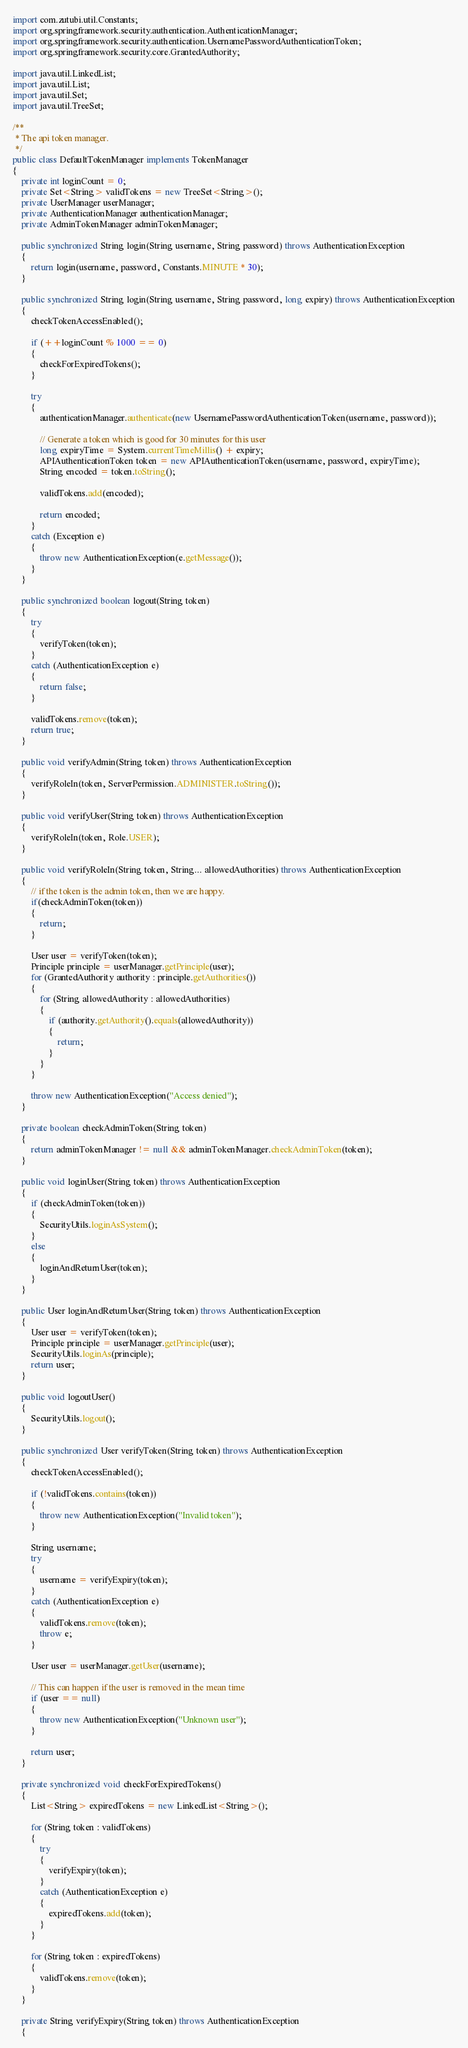<code> <loc_0><loc_0><loc_500><loc_500><_Java_>import com.zutubi.util.Constants;
import org.springframework.security.authentication.AuthenticationManager;
import org.springframework.security.authentication.UsernamePasswordAuthenticationToken;
import org.springframework.security.core.GrantedAuthority;

import java.util.LinkedList;
import java.util.List;
import java.util.Set;
import java.util.TreeSet;

/**
 * The api token manager.
 */
public class DefaultTokenManager implements TokenManager
{
    private int loginCount = 0;
    private Set<String> validTokens = new TreeSet<String>();
    private UserManager userManager;
    private AuthenticationManager authenticationManager;
    private AdminTokenManager adminTokenManager;

    public synchronized String login(String username, String password) throws AuthenticationException
    {
        return login(username, password, Constants.MINUTE * 30);
    }

    public synchronized String login(String username, String password, long expiry) throws AuthenticationException
    {
        checkTokenAccessEnabled();

        if (++loginCount % 1000 == 0)
        {
            checkForExpiredTokens();
        }

        try
        {
            authenticationManager.authenticate(new UsernamePasswordAuthenticationToken(username, password));

            // Generate a token which is good for 30 minutes for this user
            long expiryTime = System.currentTimeMillis() + expiry;
            APIAuthenticationToken token = new APIAuthenticationToken(username, password, expiryTime);
            String encoded = token.toString();

            validTokens.add(encoded);

            return encoded;
        }
        catch (Exception e)
        {
            throw new AuthenticationException(e.getMessage());
        }
    }

    public synchronized boolean logout(String token)
    {
        try
        {
            verifyToken(token);
        }
        catch (AuthenticationException e)
        {
            return false;
        }

        validTokens.remove(token);
        return true;
    }

    public void verifyAdmin(String token) throws AuthenticationException
    {
        verifyRoleIn(token, ServerPermission.ADMINISTER.toString());
    }

    public void verifyUser(String token) throws AuthenticationException
    {
        verifyRoleIn(token, Role.USER);
    }

    public void verifyRoleIn(String token, String... allowedAuthorities) throws AuthenticationException
    {
        // if the token is the admin token, then we are happy.
        if(checkAdminToken(token))
        {
            return;
        }

        User user = verifyToken(token);
        Principle principle = userManager.getPrinciple(user);
        for (GrantedAuthority authority : principle.getAuthorities())
        {
            for (String allowedAuthority : allowedAuthorities)
            {
                if (authority.getAuthority().equals(allowedAuthority))
                {
                    return;
                }
            }
        }

        throw new AuthenticationException("Access denied");
    }

    private boolean checkAdminToken(String token)
    {
        return adminTokenManager != null && adminTokenManager.checkAdminToken(token);
    }

    public void loginUser(String token) throws AuthenticationException
    {
        if (checkAdminToken(token))
        {
            SecurityUtils.loginAsSystem();
        }
        else
        {
            loginAndReturnUser(token);
        }
    }

    public User loginAndReturnUser(String token) throws AuthenticationException
    {
        User user = verifyToken(token);
        Principle principle = userManager.getPrinciple(user);
        SecurityUtils.loginAs(principle);
        return user;
    }

    public void logoutUser()
    {
        SecurityUtils.logout();
    }

    public synchronized User verifyToken(String token) throws AuthenticationException
    {
        checkTokenAccessEnabled();

        if (!validTokens.contains(token))
        {
            throw new AuthenticationException("Invalid token");
        }

        String username;
        try
        {
            username = verifyExpiry(token);
        }
        catch (AuthenticationException e)
        {
            validTokens.remove(token);
            throw e;
        }

        User user = userManager.getUser(username);

        // This can happen if the user is removed in the mean time
        if (user == null)
        {
            throw new AuthenticationException("Unknown user");
        }

        return user;
    }

    private synchronized void checkForExpiredTokens()
    {
        List<String> expiredTokens = new LinkedList<String>();

        for (String token : validTokens)
        {
            try
            {
                verifyExpiry(token);
            }
            catch (AuthenticationException e)
            {
                expiredTokens.add(token);
            }
        }

        for (String token : expiredTokens)
        {
            validTokens.remove(token);
        }
    }

    private String verifyExpiry(String token) throws AuthenticationException
    {</code> 